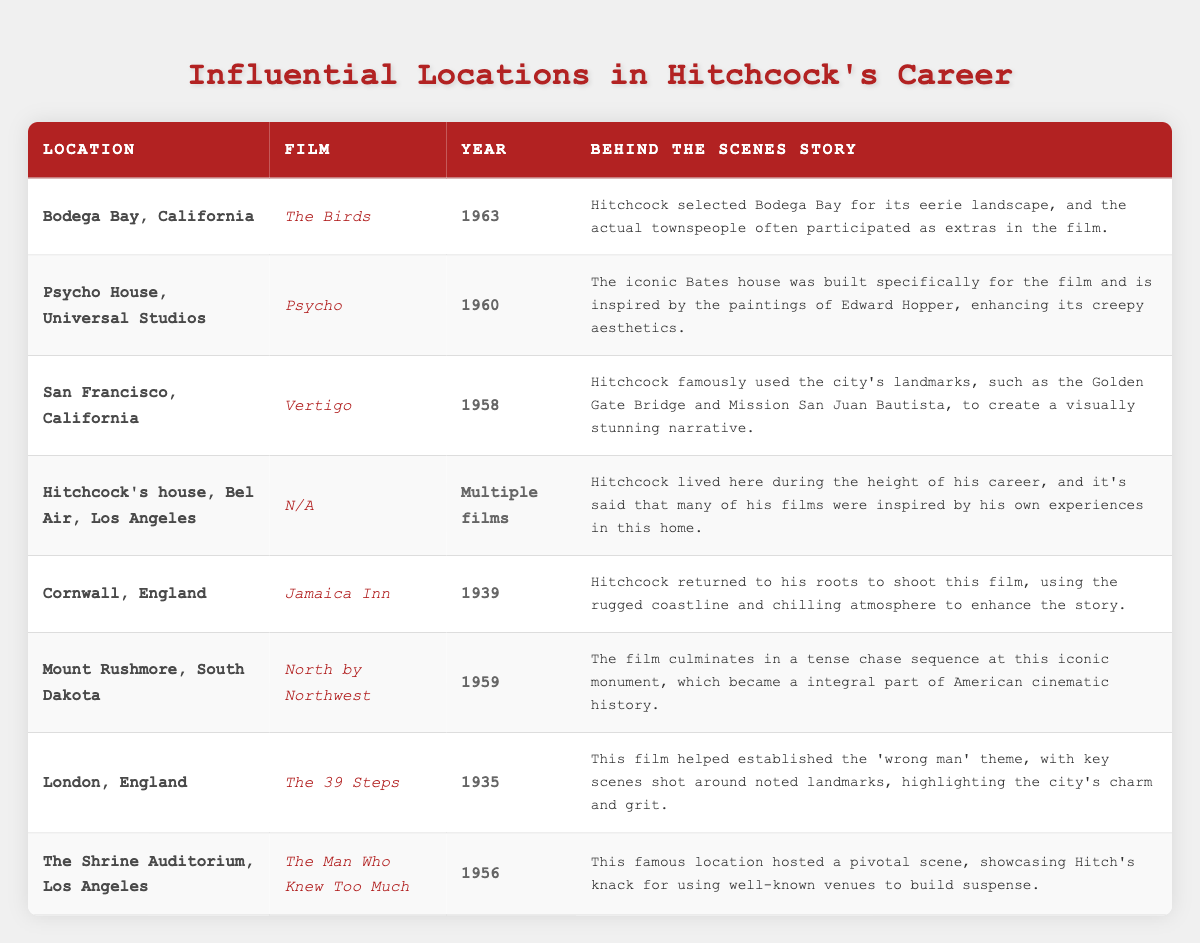What movie was filmed in Bodega Bay, California? The table indicates that the location Bodega Bay, California is associated with the film The Birds.
Answer: The Birds In what year was Psycho released? From the table, it shows that the film Psycho was released in 1960.
Answer: 1960 Which location is associated with North by Northwest? According to the table, the location associated with North by Northwest is Mount Rushmore, South Dakota.
Answer: Mount Rushmore, South Dakota Did Hitchcock film any movies at his house in Bel Air? The table states that Hitchcock's house has been a location for multiple films, even though it does not specify which ones.
Answer: Yes What location appears in the film Vertigo? The film Vertigo is associated with the location San Francisco, California, as indicated in the table.
Answer: San Francisco, California Which film features the Shrine Auditorium? The table shows that the Shrine Auditorium is featured in the film The Man Who Knew Too Much.
Answer: The Man Who Knew Too Much How many films were linked to locations in England? The table lists two entries tied to England: Jamaica Inn (Cornwall) and The 39 Steps (London), which totals to two films.
Answer: 2 What is the behind-the-scenes story for The Birds? The table provides that the behind-the-scenes story for The Birds mentions Hitchcock selecting Bodega Bay for its eerie landscape, with townspeople as extras.
Answer: Hitchcock chose Bodega Bay for its eerie landscape and townspeople were extras Which film was influenced by Edward Hopper's paintings? The table notes that Psycho was influenced by Edward Hopper's paintings, particularly in the design of the Bates house.
Answer: Psycho Which two films were released in the 1950s and involved iconic locations? The listed films released in the 1950s with iconic locations are Vertigo (1958) and North by Northwest (1959), summing to two films.
Answer: 2 Which location was featured in a film released before 1940? The film Jamaica Inn, shot in Cornwall, England in 1939, meets the criteria since it has a release date before 1940.
Answer: Cornwall, England What was Hitchcock's connection to his house in Bel Air? The table reveals that Hitchcock lived in his Bel Air house during his peak career and found inspiration for many of his films from his experiences there.
Answer: He lived there and drew inspiration for his films What unique aspect did Mount Rushmore contribute to North by Northwest? The table states that Mount Rushmore featured a tense chase sequence in North by Northwest, becoming a significant part of cinematic history.
Answer: A tense chase sequence Did Hitchcock use San Francisco landmarks in his filming? The table illustrates that in Vertigo, Hitchcock famously used San Francisco’s landmarks such as the Golden Gate Bridge, indicating he did use them.
Answer: Yes 